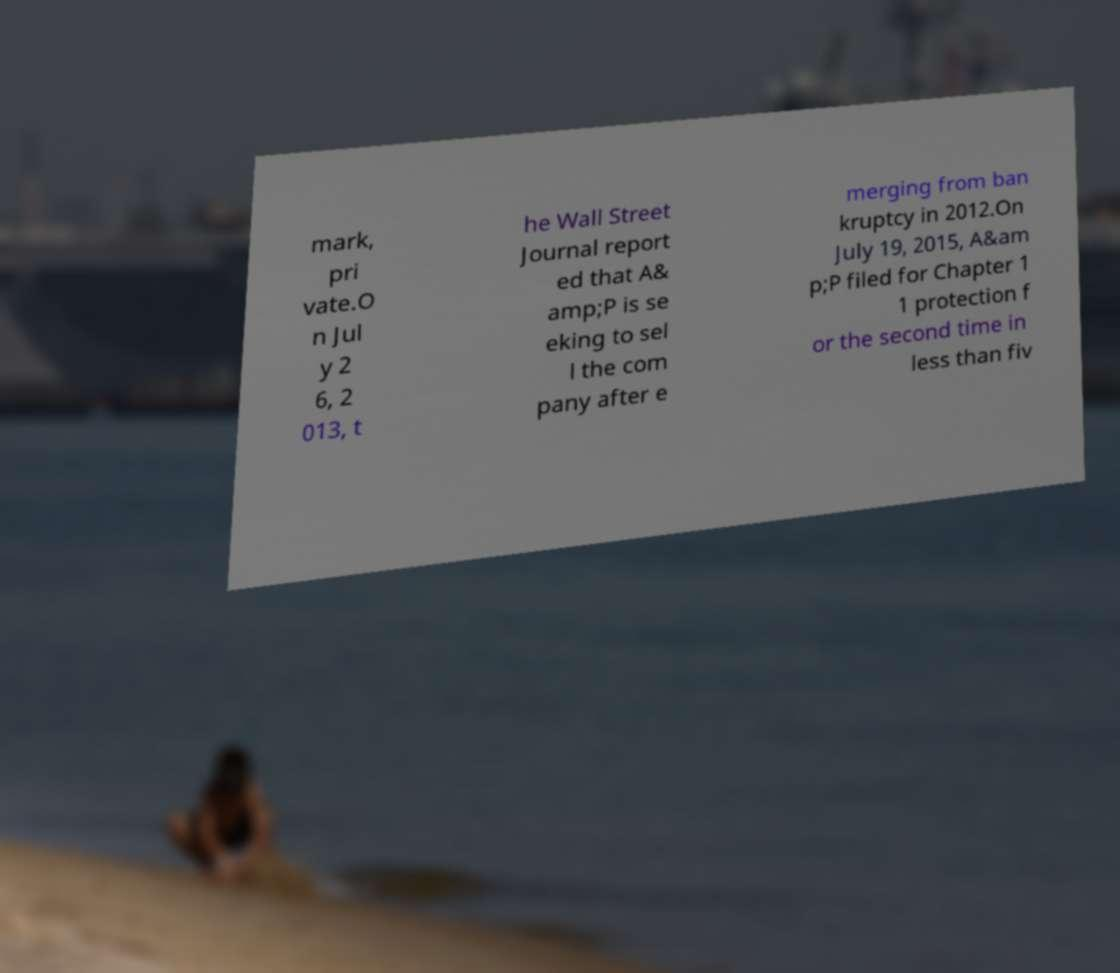Please identify and transcribe the text found in this image. mark, pri vate.O n Jul y 2 6, 2 013, t he Wall Street Journal report ed that A& amp;P is se eking to sel l the com pany after e merging from ban kruptcy in 2012.On July 19, 2015, A&am p;P filed for Chapter 1 1 protection f or the second time in less than fiv 